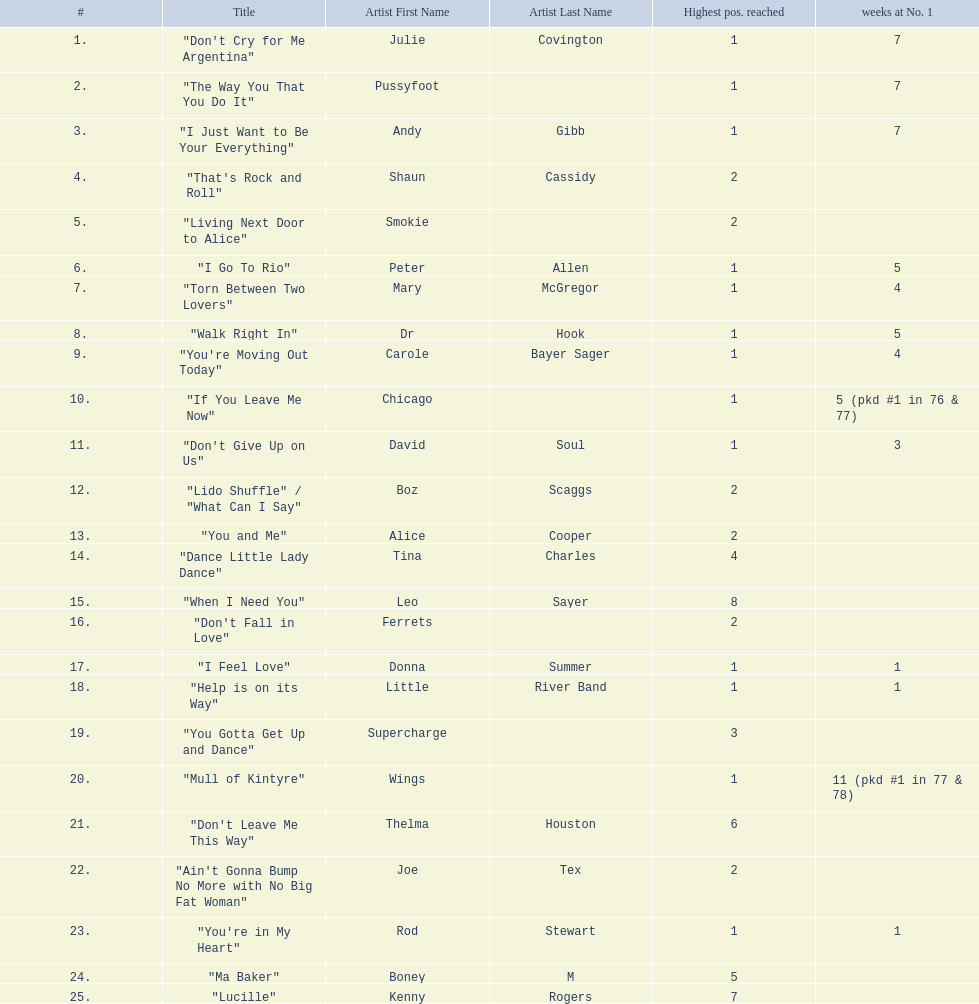Who had the most weeks at number one, according to the table? Wings. 